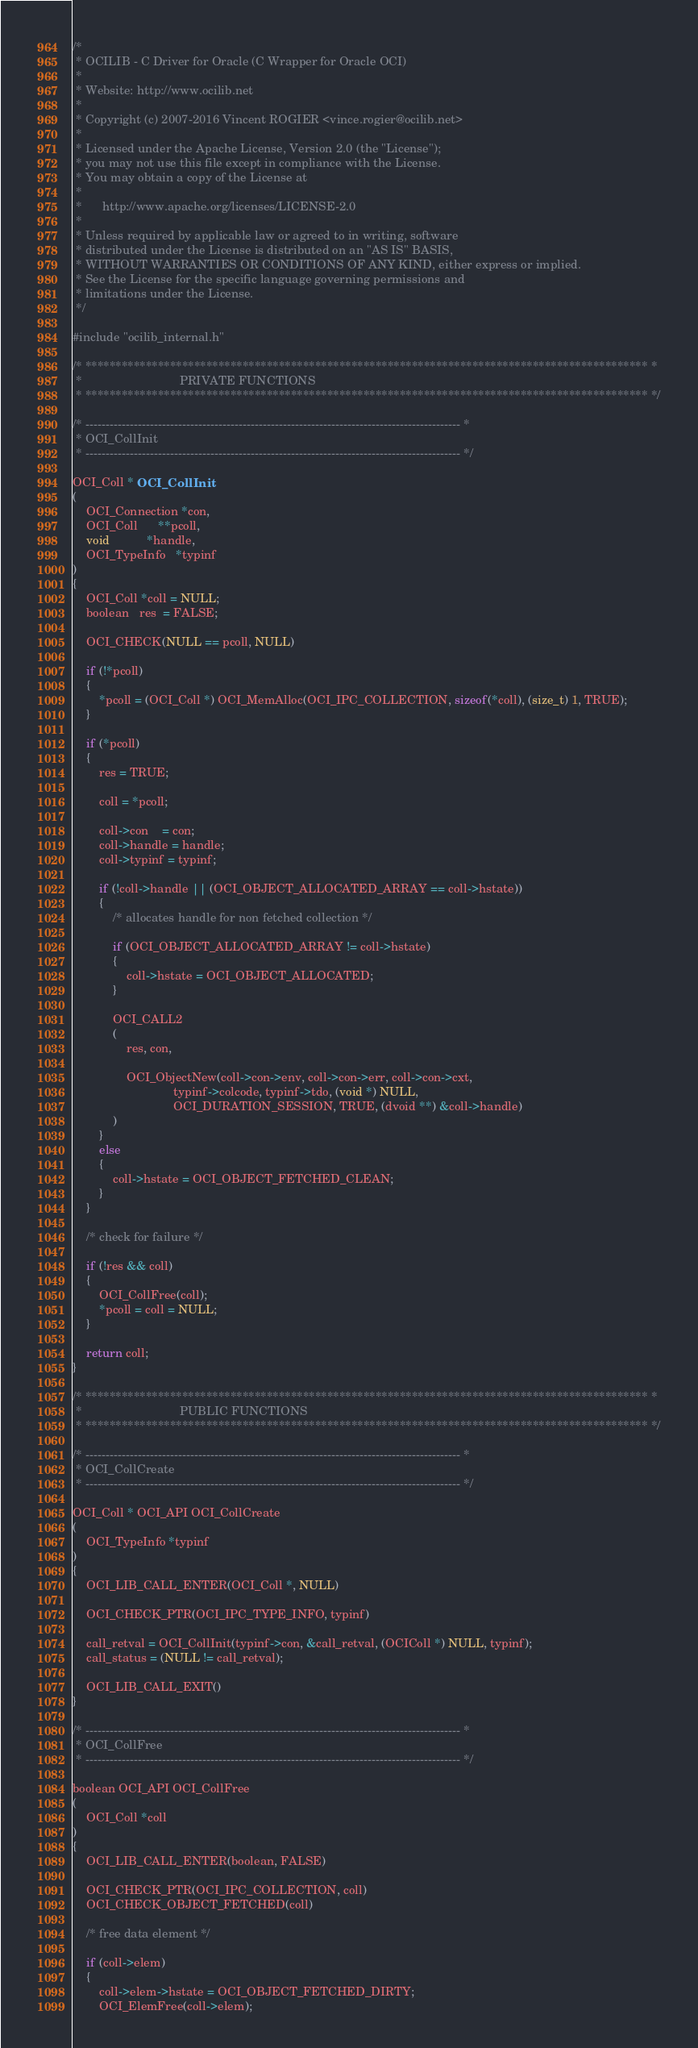<code> <loc_0><loc_0><loc_500><loc_500><_C_>/*
 * OCILIB - C Driver for Oracle (C Wrapper for Oracle OCI)
 *
 * Website: http://www.ocilib.net
 *
 * Copyright (c) 2007-2016 Vincent ROGIER <vince.rogier@ocilib.net>
 *
 * Licensed under the Apache License, Version 2.0 (the "License");
 * you may not use this file except in compliance with the License.
 * You may obtain a copy of the License at
 *
 *      http://www.apache.org/licenses/LICENSE-2.0
 *
 * Unless required by applicable law or agreed to in writing, software
 * distributed under the License is distributed on an "AS IS" BASIS,
 * WITHOUT WARRANTIES OR CONDITIONS OF ANY KIND, either express or implied.
 * See the License for the specific language governing permissions and
 * limitations under the License.
 */

#include "ocilib_internal.h"

/* ********************************************************************************************* *
 *                             PRIVATE FUNCTIONS
 * ********************************************************************************************* */

/* --------------------------------------------------------------------------------------------- *
 * OCI_CollInit
 * --------------------------------------------------------------------------------------------- */

OCI_Coll * OCI_CollInit
(
    OCI_Connection *con,
    OCI_Coll      **pcoll,
    void           *handle,
    OCI_TypeInfo   *typinf
)
{
    OCI_Coll *coll = NULL;
    boolean   res  = FALSE;

    OCI_CHECK(NULL == pcoll, NULL)

    if (!*pcoll)
    {
        *pcoll = (OCI_Coll *) OCI_MemAlloc(OCI_IPC_COLLECTION, sizeof(*coll), (size_t) 1, TRUE);
    }

    if (*pcoll)
    {
        res = TRUE;

        coll = *pcoll;

        coll->con    = con;
        coll->handle = handle;
        coll->typinf = typinf;

        if (!coll->handle || (OCI_OBJECT_ALLOCATED_ARRAY == coll->hstate))
        {
            /* allocates handle for non fetched collection */

            if (OCI_OBJECT_ALLOCATED_ARRAY != coll->hstate)
            {
                coll->hstate = OCI_OBJECT_ALLOCATED;
            }

            OCI_CALL2
            (
                res, con,

                OCI_ObjectNew(coll->con->env, coll->con->err, coll->con->cxt,
                              typinf->colcode, typinf->tdo, (void *) NULL,
                              OCI_DURATION_SESSION, TRUE, (dvoid **) &coll->handle)
            )
        }
        else
        {
            coll->hstate = OCI_OBJECT_FETCHED_CLEAN;
        }
    }

    /* check for failure */

    if (!res && coll)
    {
        OCI_CollFree(coll);
        *pcoll = coll = NULL;
    }

    return coll;
}

/* ********************************************************************************************* *
 *                             PUBLIC FUNCTIONS
 * ********************************************************************************************* */

/* --------------------------------------------------------------------------------------------- *
 * OCI_CollCreate
 * --------------------------------------------------------------------------------------------- */

OCI_Coll * OCI_API OCI_CollCreate
(
    OCI_TypeInfo *typinf
)
{
    OCI_LIB_CALL_ENTER(OCI_Coll *, NULL)

    OCI_CHECK_PTR(OCI_IPC_TYPE_INFO, typinf)

    call_retval = OCI_CollInit(typinf->con, &call_retval, (OCIColl *) NULL, typinf);
    call_status = (NULL != call_retval);

    OCI_LIB_CALL_EXIT()
}

/* --------------------------------------------------------------------------------------------- *
 * OCI_CollFree
 * --------------------------------------------------------------------------------------------- */

boolean OCI_API OCI_CollFree
(
    OCI_Coll *coll
)
{
    OCI_LIB_CALL_ENTER(boolean, FALSE)

    OCI_CHECK_PTR(OCI_IPC_COLLECTION, coll)
    OCI_CHECK_OBJECT_FETCHED(coll)

    /* free data element */

    if (coll->elem)
    {
        coll->elem->hstate = OCI_OBJECT_FETCHED_DIRTY;
        OCI_ElemFree(coll->elem);</code> 